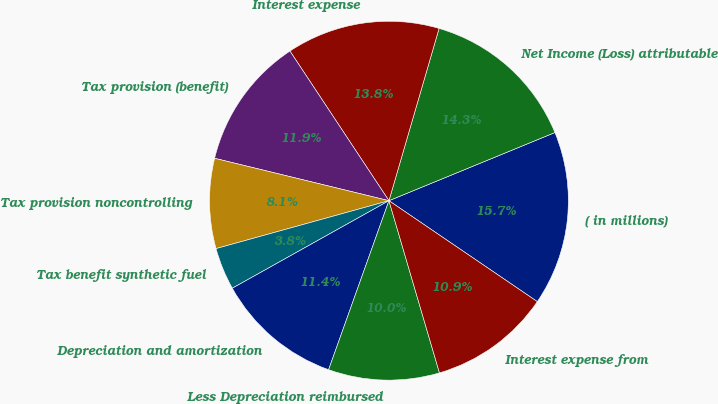Convert chart. <chart><loc_0><loc_0><loc_500><loc_500><pie_chart><fcel>( in millions)<fcel>Net Income (Loss) attributable<fcel>Interest expense<fcel>Tax provision (benefit)<fcel>Tax provision noncontrolling<fcel>Tax benefit synthetic fuel<fcel>Depreciation and amortization<fcel>Less Depreciation reimbursed<fcel>Interest expense from<nl><fcel>15.71%<fcel>14.29%<fcel>13.81%<fcel>11.9%<fcel>8.1%<fcel>3.81%<fcel>11.43%<fcel>10.0%<fcel>10.95%<nl></chart> 